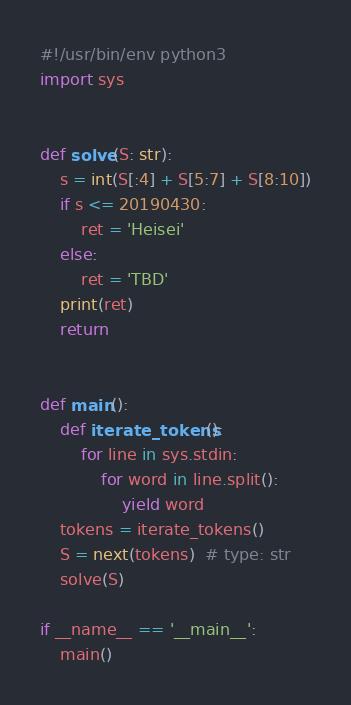Convert code to text. <code><loc_0><loc_0><loc_500><loc_500><_Python_>#!/usr/bin/env python3
import sys


def solve(S: str):
    s = int(S[:4] + S[5:7] + S[8:10])
    if s <= 20190430:
        ret = 'Heisei'
    else:
        ret = 'TBD'
    print(ret)
    return


def main():
    def iterate_tokens():
        for line in sys.stdin:
            for word in line.split():
                yield word
    tokens = iterate_tokens()
    S = next(tokens)  # type: str
    solve(S)

if __name__ == '__main__':
    main()
</code> 